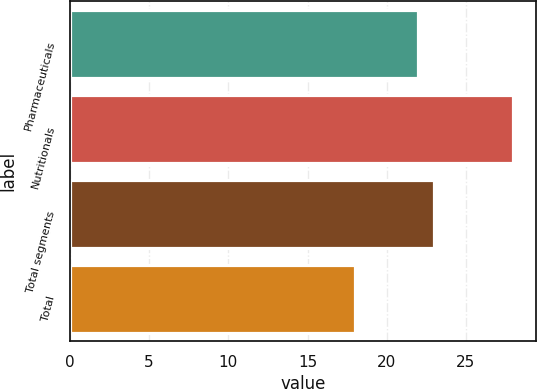Convert chart. <chart><loc_0><loc_0><loc_500><loc_500><bar_chart><fcel>Pharmaceuticals<fcel>Nutritionals<fcel>Total segments<fcel>Total<nl><fcel>22<fcel>28<fcel>23<fcel>18<nl></chart> 